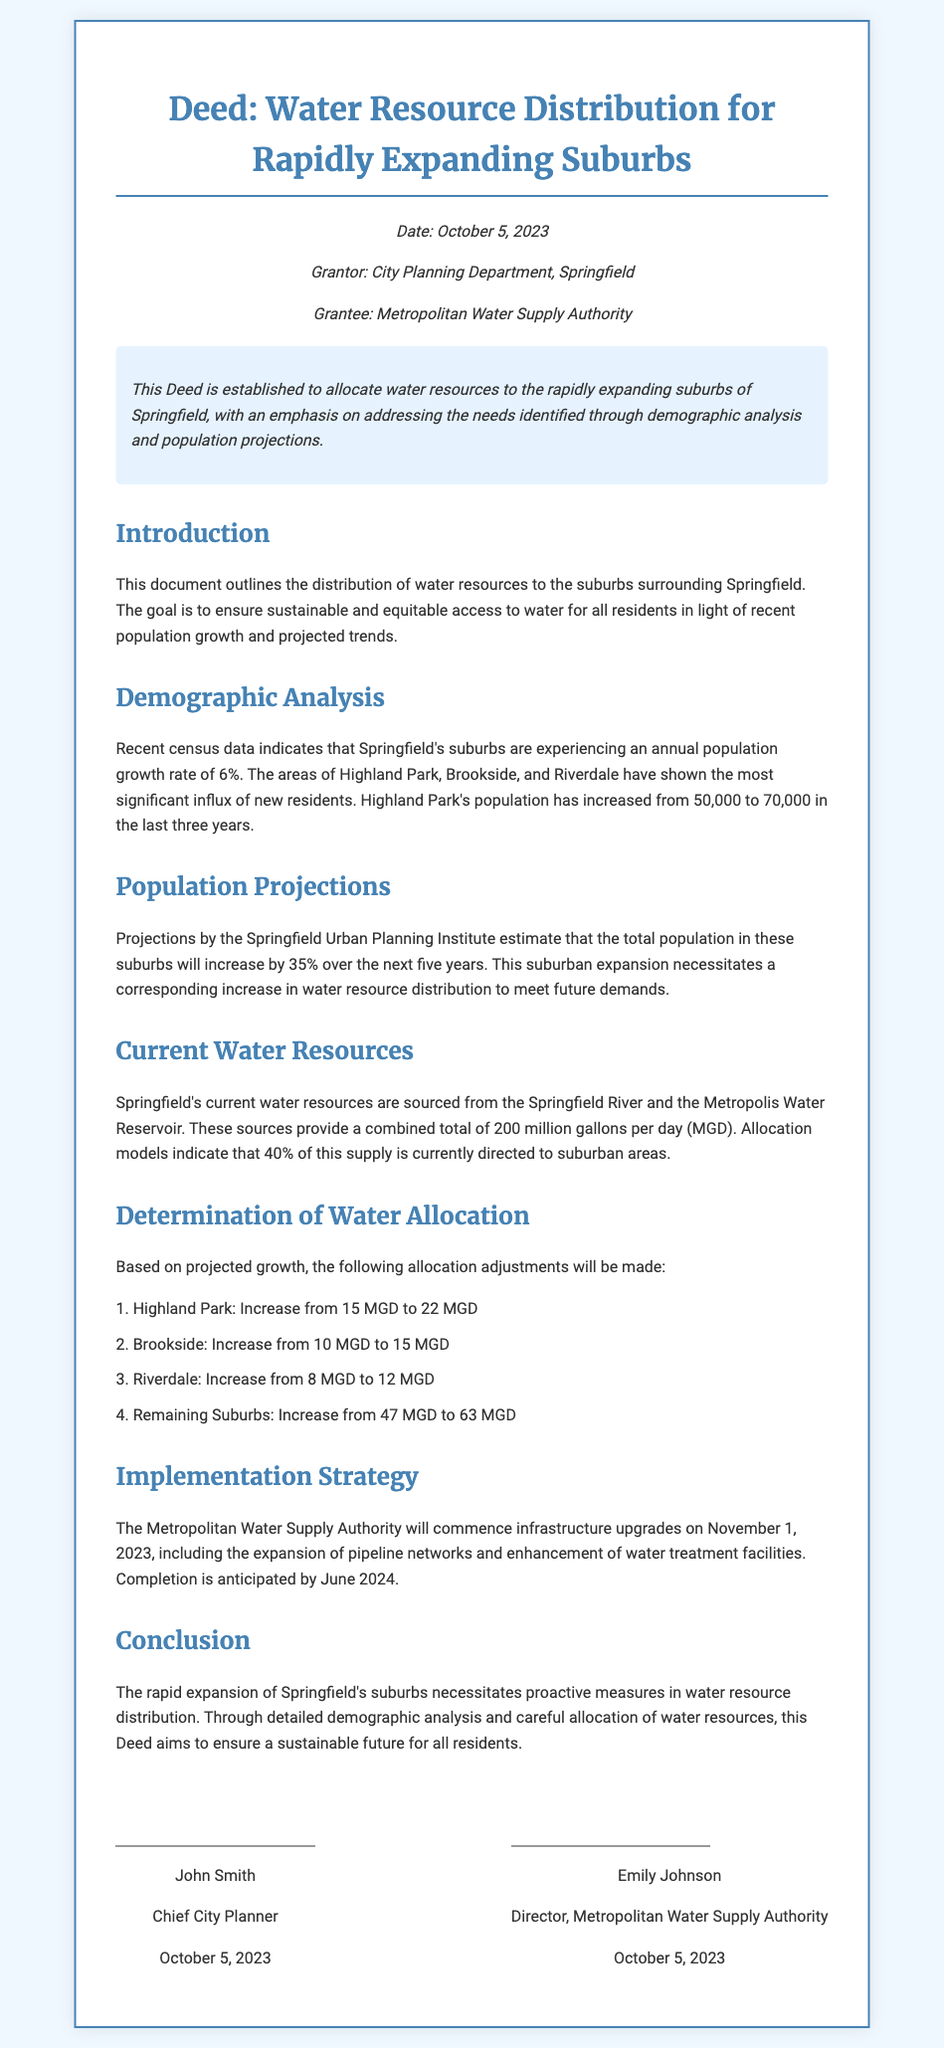What is the date of the deed? The date is stated in the document as October 5, 2023.
Answer: October 5, 2023 Who is the grantor of the deed? The grantor is identified in the metadata section of the document.
Answer: City Planning Department, Springfield What is the annual population growth rate in the suburbs? The annual population growth rate is mentioned in the demographic analysis section.
Answer: 6% How much water will be allocated to Highland Park? The allocation amount for Highland Park is specified in the determination of water allocation section.
Answer: 22 MGD When will the infrastructure upgrades commence? The implementation strategy outlines the commencement date for upgrades.
Answer: November 1, 2023 What is the current total water resource supply? Total water resource supply is provided in the current water resources section.
Answer: 200 million gallons per day How much will water allocation for remaining suburbs increase? The increase for remaining suburbs is specified in the determination of water allocation section.
Answer: 16 MGD Who is the director of the Metropolitan Water Supply Authority? The director's name is provided in the signatures section of the document.
Answer: Emily Johnson What is the completion date anticipated for the infrastructure enhancements? The anticipated completion date is mentioned in the implementation strategy.
Answer: June 2024 